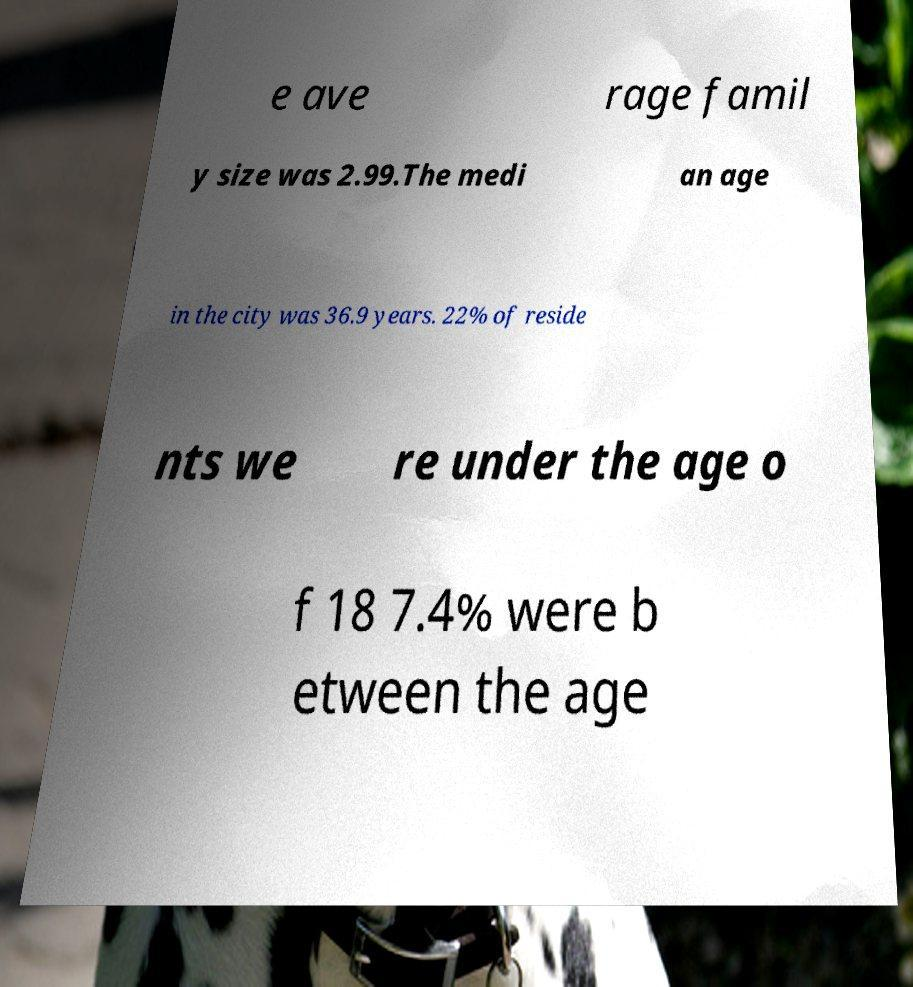Can you accurately transcribe the text from the provided image for me? e ave rage famil y size was 2.99.The medi an age in the city was 36.9 years. 22% of reside nts we re under the age o f 18 7.4% were b etween the age 